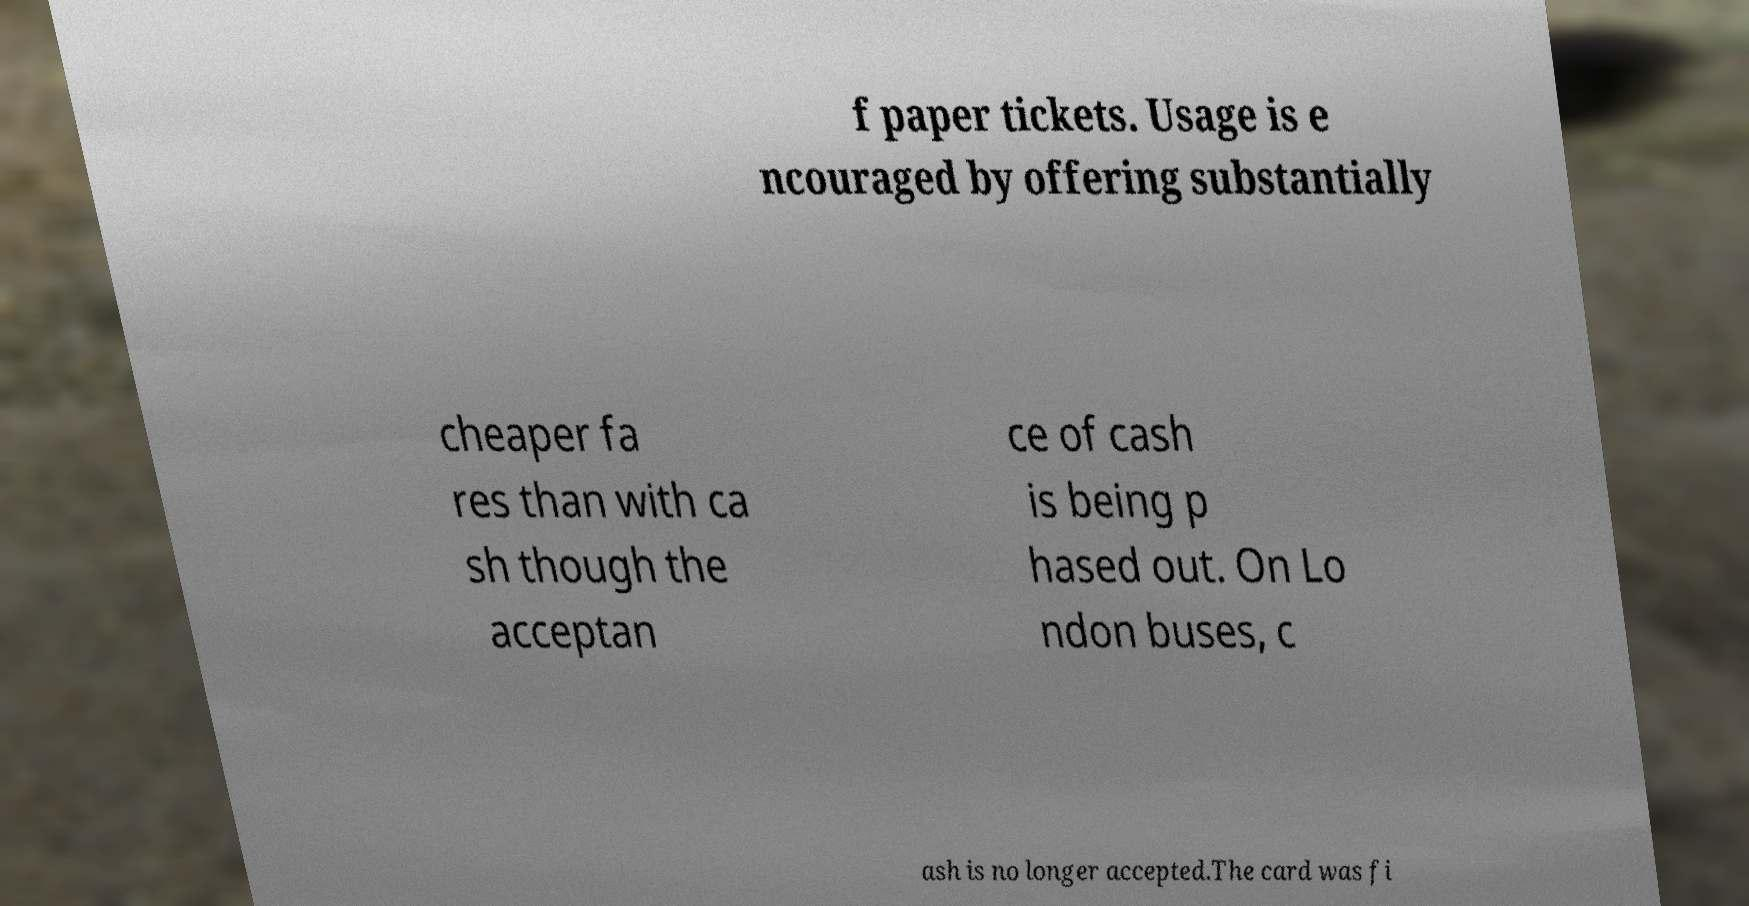For documentation purposes, I need the text within this image transcribed. Could you provide that? f paper tickets. Usage is e ncouraged by offering substantially cheaper fa res than with ca sh though the acceptan ce of cash is being p hased out. On Lo ndon buses, c ash is no longer accepted.The card was fi 